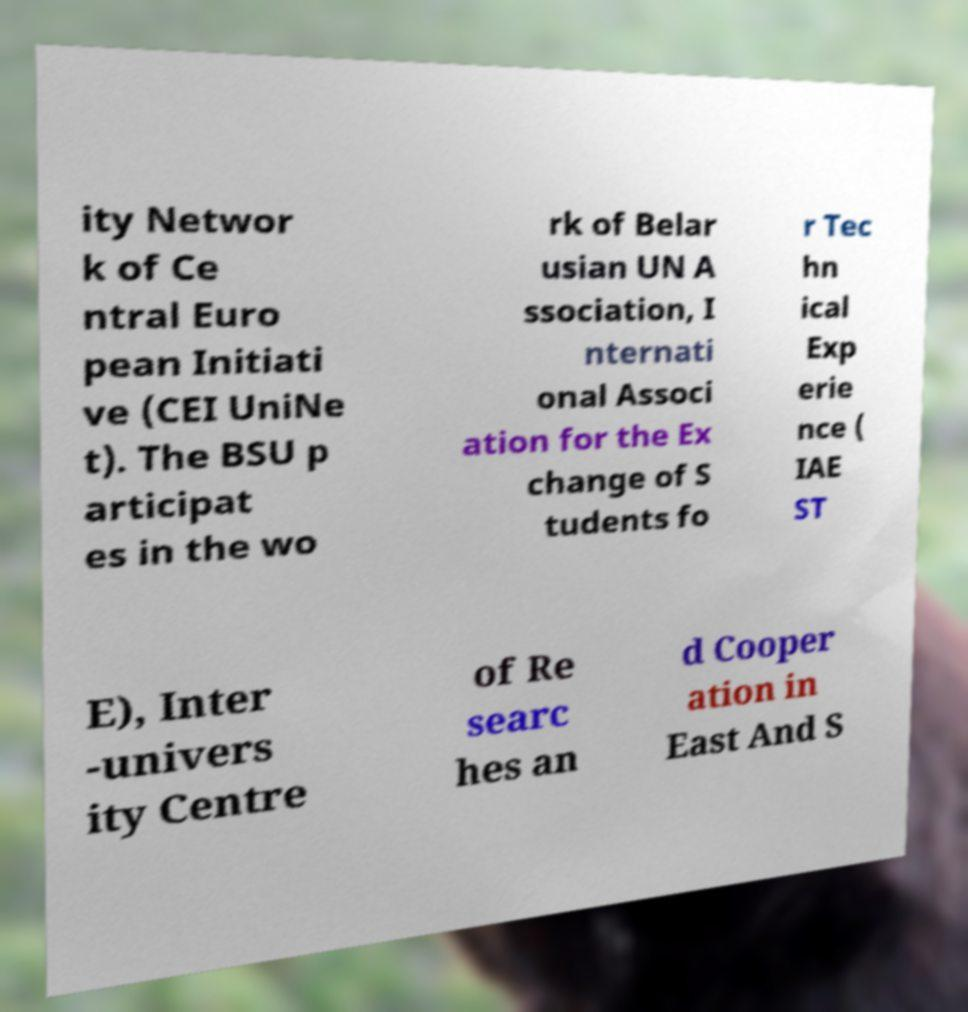Please read and relay the text visible in this image. What does it say? ity Networ k of Ce ntral Euro pean Initiati ve (CEI UniNe t). The BSU p articipat es in the wo rk of Belar usian UN A ssociation, I nternati onal Associ ation for the Ex change of S tudents fo r Tec hn ical Exp erie nce ( IAE ST E), Inter -univers ity Centre of Re searc hes an d Cooper ation in East And S 